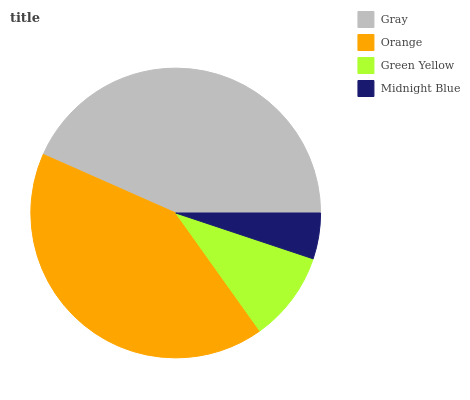Is Midnight Blue the minimum?
Answer yes or no. Yes. Is Gray the maximum?
Answer yes or no. Yes. Is Orange the minimum?
Answer yes or no. No. Is Orange the maximum?
Answer yes or no. No. Is Gray greater than Orange?
Answer yes or no. Yes. Is Orange less than Gray?
Answer yes or no. Yes. Is Orange greater than Gray?
Answer yes or no. No. Is Gray less than Orange?
Answer yes or no. No. Is Orange the high median?
Answer yes or no. Yes. Is Green Yellow the low median?
Answer yes or no. Yes. Is Gray the high median?
Answer yes or no. No. Is Gray the low median?
Answer yes or no. No. 